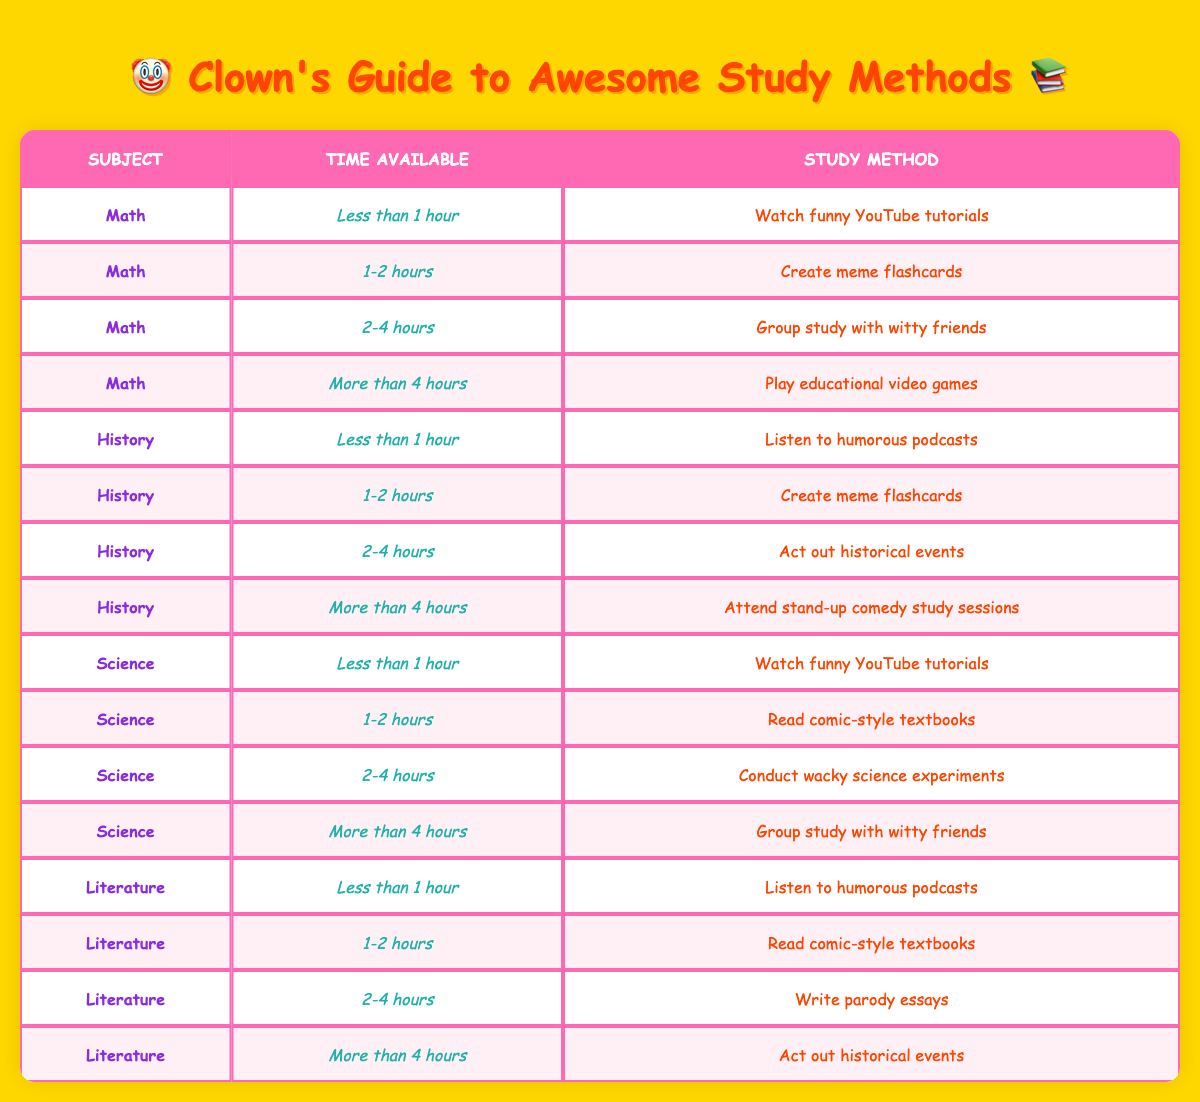What study method is recommended for Math with less than 1 hour available? The table indicates that for Math, when the time available is less than 1 hour, the recommended study method is to watch funny YouTube tutorials. This can be directly retrieved from the corresponding row in the table.
Answer: Watch funny YouTube tutorials If I have 2-4 hours to study Science, what method should I use? Looking at the table, for Science with 2-4 hours available, the method listed is to conduct wacky science experiments. This is stated in the row that corresponds to Science and the time frame of 2-4 hours.
Answer: Conduct wacky science experiments Does the study method for History change if I have 1-2 hours or 2-4 hours available? According to the table, the study method for History with 1-2 hours is to create meme flashcards, while for 2-4 hours, it's to act out historical events. Since these are two different methods, the answer is yes, the method does change.
Answer: Yes What is the total number of recommended study methods for each subject? We need to count the unique study methods for each subject: Math has 4, History has 4, Science has 4, and Literature has 4. Adding these gives a total of 4 + 4 + 4 + 4 = 16 unique study methods across all subjects.
Answer: 16 Are there any subjects that suggest listening to humorous podcasts? The table shows that both History and Literature suggest listening to humorous podcasts when less than 1 hour is available. This can be confirmed by checking those specific entries in the table.
Answer: Yes What study method is recommended for Literature when there is more than 4 hours available? By examining the Literature section of the table, the method recommended when there is more than 4 hours available is to act out historical events. This is listed in the corresponding row for Literature and time.
Answer: Act out historical events Which study method is common for both Math and Science when less than 1 hour is available? The table highlights that both Math and Science recommend watching funny YouTube tutorials when the time available is less than 1 hour. This is evident in both subjects’ rows for that time frame.
Answer: Watch funny YouTube tutorials What is the main difference between the study methods for History with less than 1 hour and more than 4 hours available? For History, the method for less than 1 hour is to listen to humorous podcasts, while for more than 4 hours, it's to attend stand-up comedy study sessions. The difference lies in the type of activity suggested for different time availabilities.
Answer: Listening to podcasts vs. comedy sessions How many study methods involve game-related activities? Looking at the table, we can identify that there are two methods involving game-related activities: "Play educational video games" under Math (more than 4 hours), and no others are directly game-related. Therefore, the total is 1.
Answer: 1 